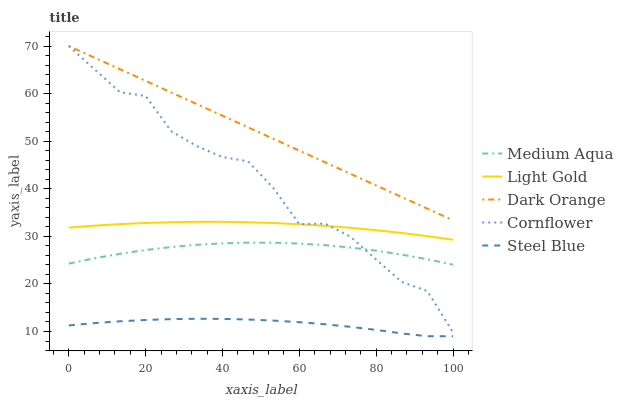Does Steel Blue have the minimum area under the curve?
Answer yes or no. Yes. Does Dark Orange have the maximum area under the curve?
Answer yes or no. Yes. Does Medium Aqua have the minimum area under the curve?
Answer yes or no. No. Does Medium Aqua have the maximum area under the curve?
Answer yes or no. No. Is Dark Orange the smoothest?
Answer yes or no. Yes. Is Cornflower the roughest?
Answer yes or no. Yes. Is Steel Blue the smoothest?
Answer yes or no. No. Is Steel Blue the roughest?
Answer yes or no. No. Does Medium Aqua have the lowest value?
Answer yes or no. No. Does Medium Aqua have the highest value?
Answer yes or no. No. Is Steel Blue less than Dark Orange?
Answer yes or no. Yes. Is Cornflower greater than Steel Blue?
Answer yes or no. Yes. Does Steel Blue intersect Dark Orange?
Answer yes or no. No. 